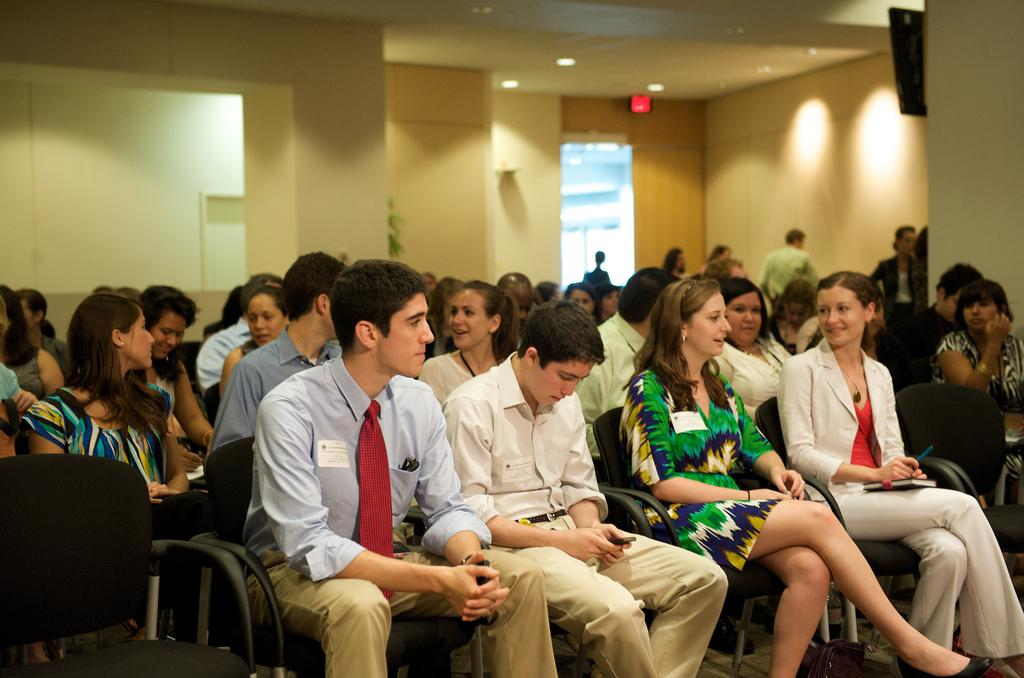Who or what can be seen in the image? There are people in the image. What are the people doing in the image? The people are sitting on chairs. What time of day is it in the image, according to the hour? There is no indication of time in the image, so it is not possible to determine the hour. 